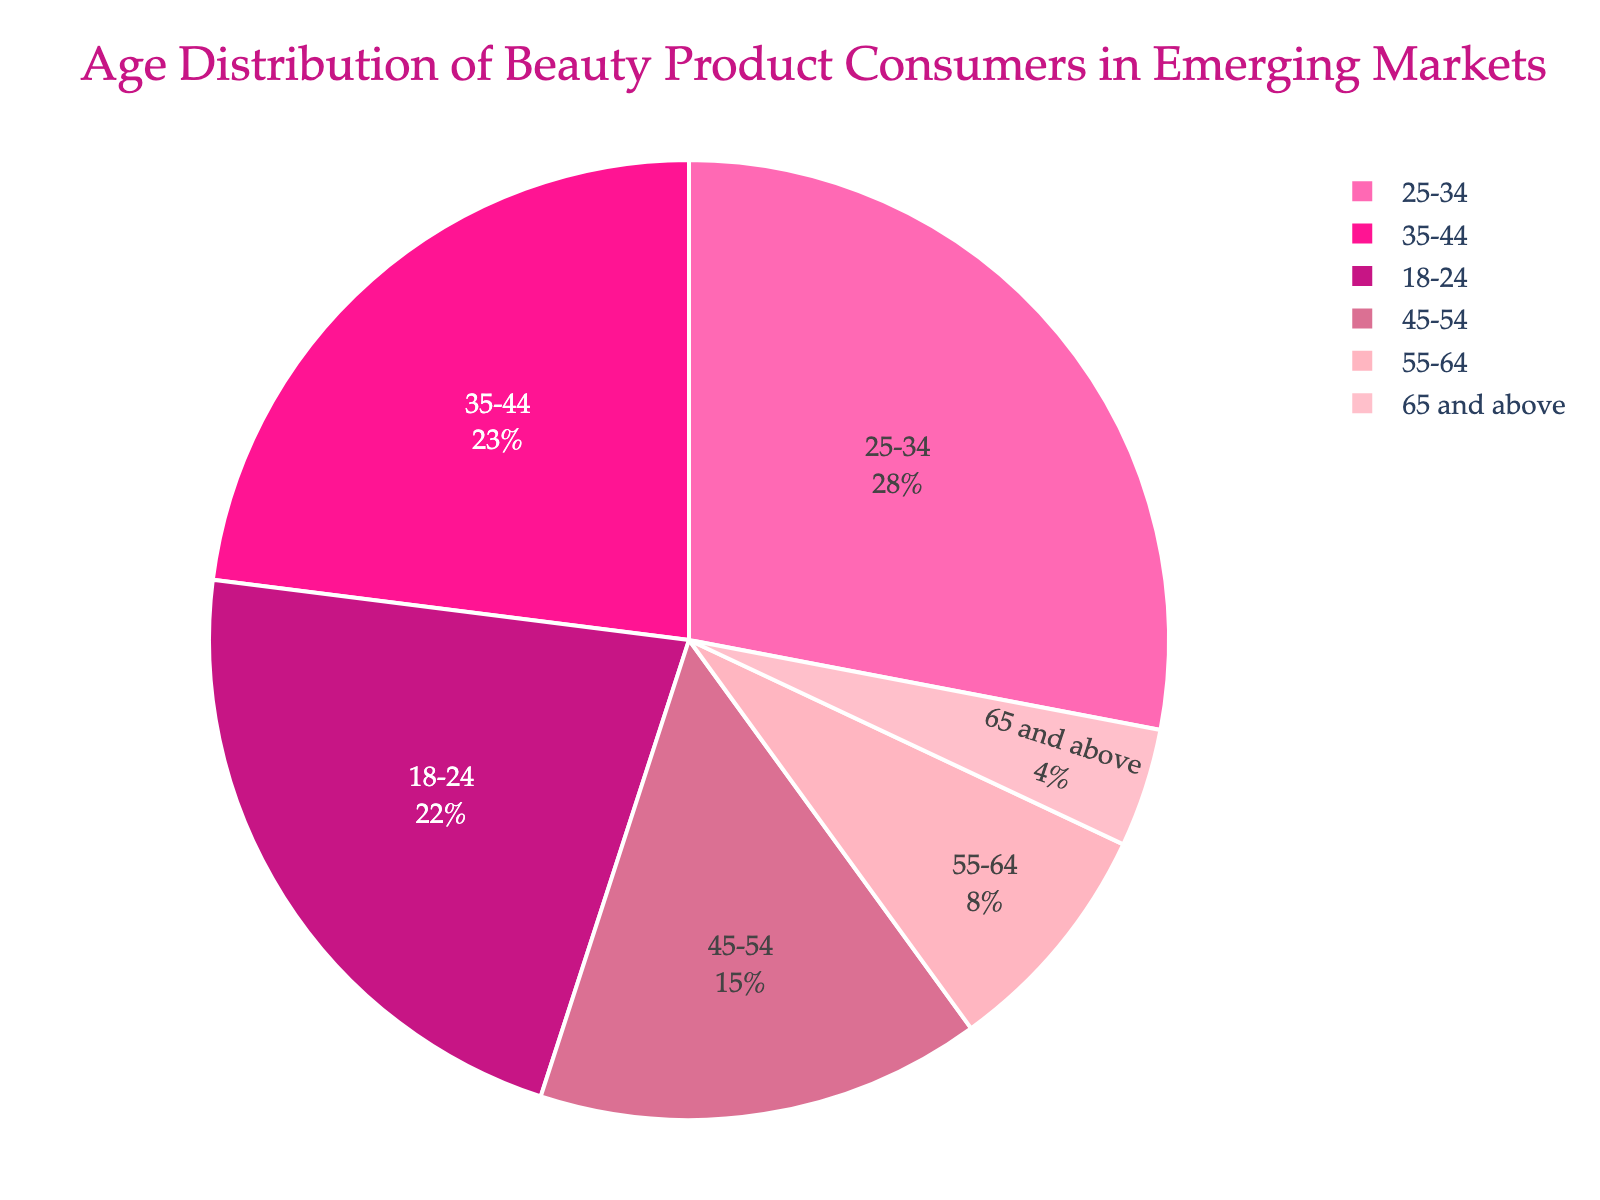What's the largest age group of beauty product consumers in emerging markets? Based on the pie chart, the largest age group is the one with the biggest slice of the pie, which is the 25-34 age group.
Answer: 25-34 Which age group is the smallest among beauty product consumers in emerging markets? By observing the pie chart, the smallest slice corresponds to the age group 65 and above.
Answer: 65 and above What's the combined percentage of beauty product consumers aged 35-54? By adding the percentages of the 35-44 and 45-54 age groups: 23% + 15% = 38%.
Answer: 38% What is the difference in percentage between the 25-34 and the 65 and above age groups? The percentage for the 25-34 age group is 28%, and for the 65 and above age group, it is 4%. The difference is 28% - 4% = 24%.
Answer: 24% Is the sum of the percentages for consumers aged 18-24 and 55-64 higher or lower than the percentage for 25-34? The sum of the percentages for 18-24 and 55-64 is 22% + 8% = 30%. The percentage for 25-34 is 28%, so 30% is higher than 28%.
Answer: Higher Which age group uses the color that's typically associated with "Deep Pink"? By observing the colors used in the pie chart and identifying the color typically associated with "Deep Pink," which is related to the hex code #FF1493, the corresponding age group is 25-34.
Answer: 25-34 What is the average percentage of the four oldest age groups (35-44, 45-54, 55-64, and 65 and above)? Adding the percentages for the four oldest age groups: 23% + 15% + 8% + 4% = 50%, then dividing by 4, the average is 50% / 4 = 12.5%.
Answer: 12.5% How much larger is the consumer base of the 18-24 age group compared to the 65 and above age group? The percentage for the 18-24 age group is 22%, and for the 65 and above age group, it is 4%. The difference is 22% - 4% = 18%.
Answer: 18% Which two age groups combined make up nearly half of the total consumer base? By identifying pairs of age groups whose combined percentages are close to 50%, the pair 25-34 and 35-44 adds up to 28% + 23% = 51%.
Answer: 25-34 and 35-44 